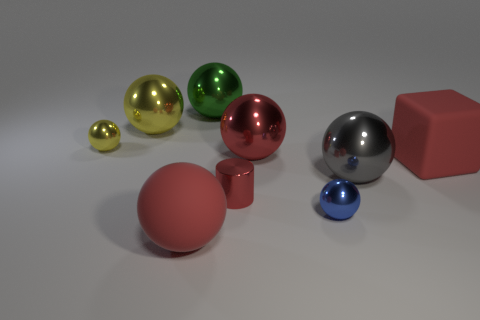Subtract all green spheres. How many spheres are left? 6 Subtract all matte balls. How many balls are left? 6 Subtract 4 spheres. How many spheres are left? 3 Subtract all red spheres. Subtract all gray blocks. How many spheres are left? 5 Add 1 red matte spheres. How many objects exist? 10 Subtract all balls. How many objects are left? 2 Subtract all big green shiny spheres. Subtract all large gray spheres. How many objects are left? 7 Add 9 blue spheres. How many blue spheres are left? 10 Add 2 tiny red metallic cylinders. How many tiny red metallic cylinders exist? 3 Subtract 0 cyan cubes. How many objects are left? 9 